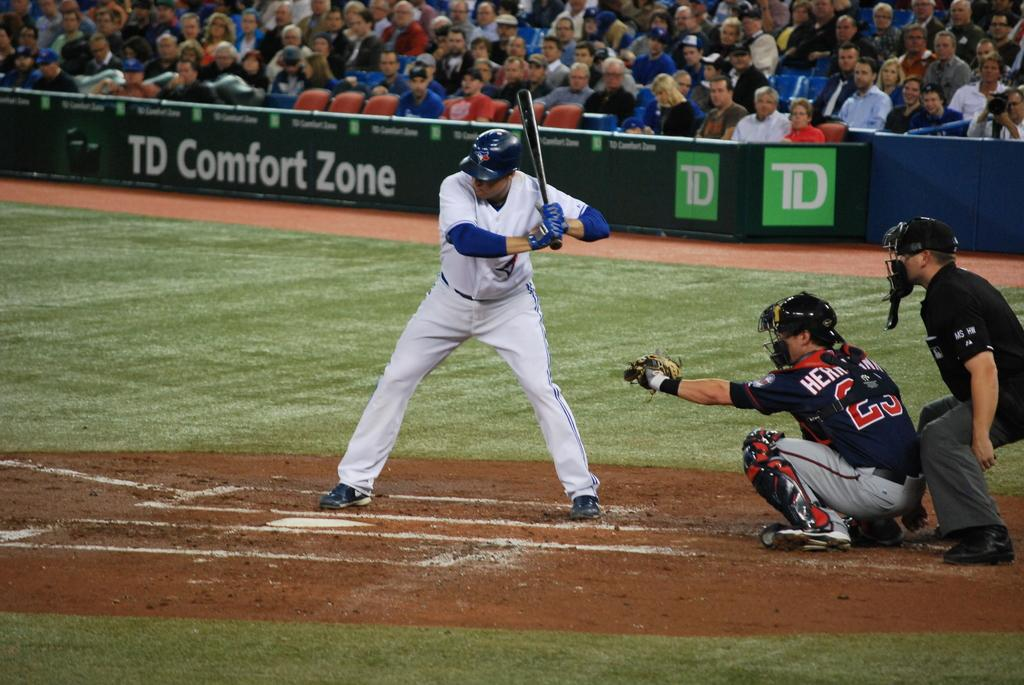<image>
Render a clear and concise summary of the photo. A baseball game sponsored by TD Comfort Zone 